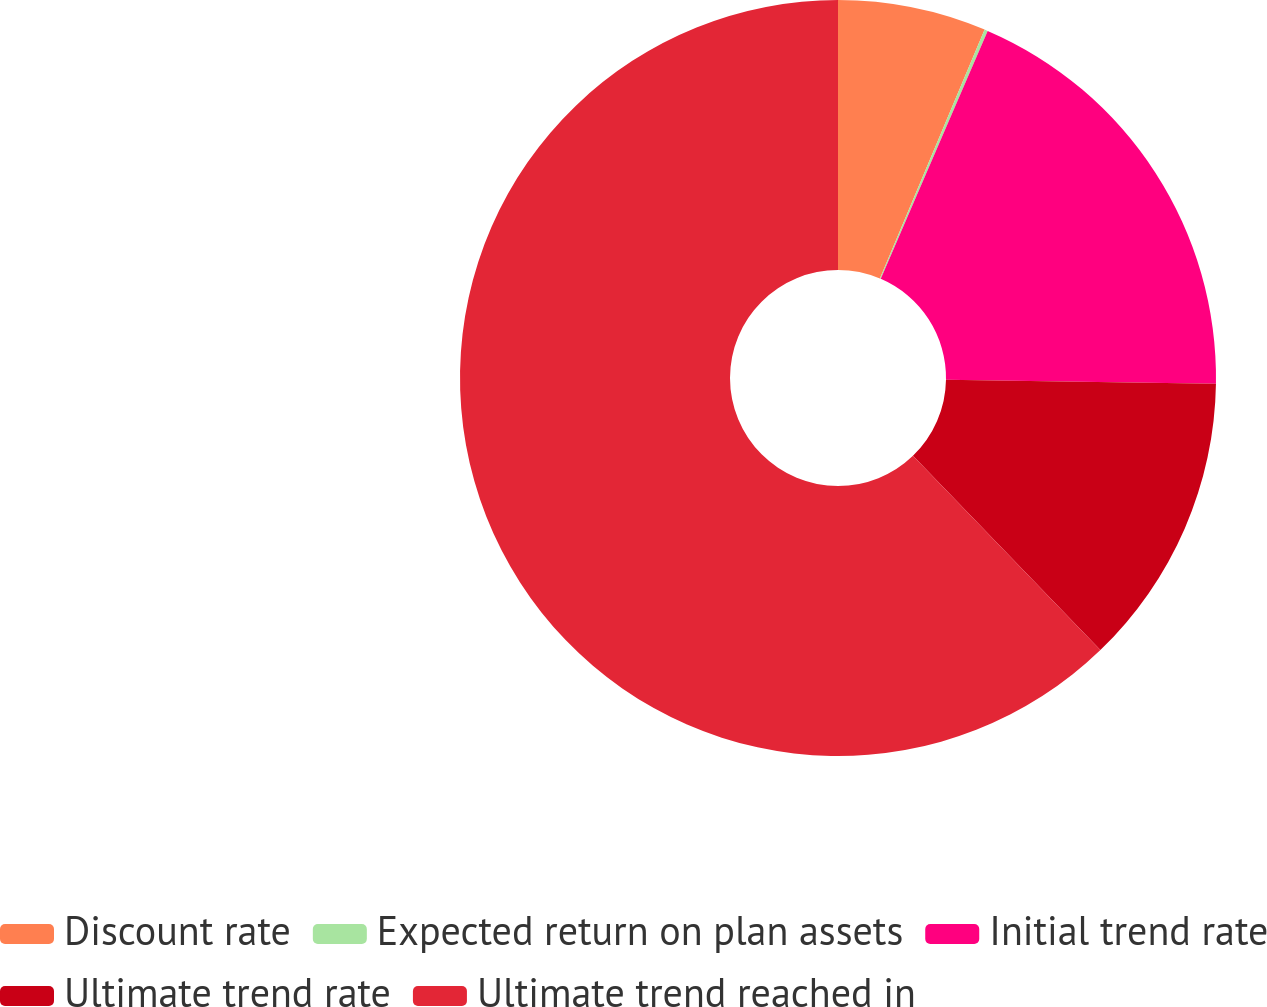Convert chart to OTSL. <chart><loc_0><loc_0><loc_500><loc_500><pie_chart><fcel>Discount rate<fcel>Expected return on plan assets<fcel>Initial trend rate<fcel>Ultimate trend rate<fcel>Ultimate trend reached in<nl><fcel>6.34%<fcel>0.14%<fcel>18.76%<fcel>12.55%<fcel>62.21%<nl></chart> 